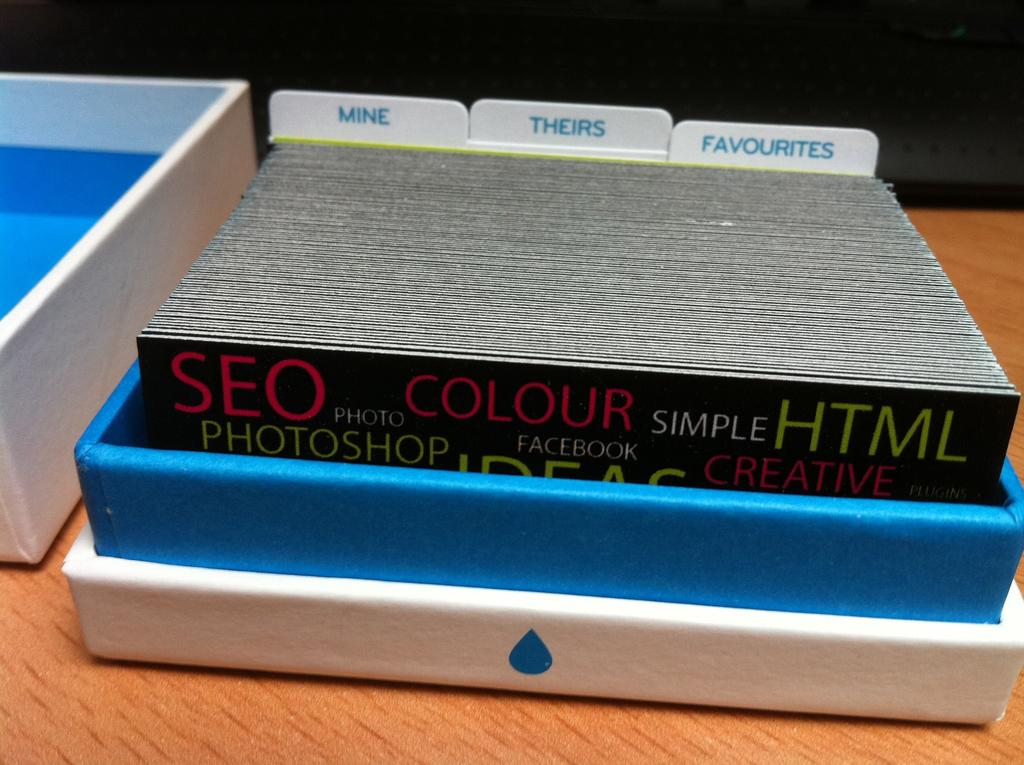<image>
Create a compact narrative representing the image presented. A deck of business cards advertising the specialties like SEO, HTML is on the desk. 